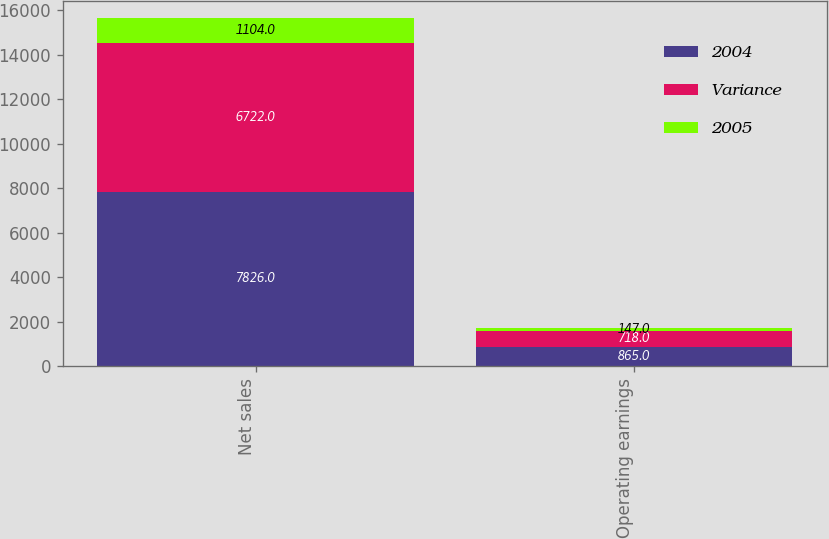Convert chart to OTSL. <chart><loc_0><loc_0><loc_500><loc_500><stacked_bar_chart><ecel><fcel>Net sales<fcel>Operating earnings<nl><fcel>2004<fcel>7826<fcel>865<nl><fcel>Variance<fcel>6722<fcel>718<nl><fcel>2005<fcel>1104<fcel>147<nl></chart> 